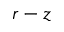Convert formula to latex. <formula><loc_0><loc_0><loc_500><loc_500>r - z</formula> 